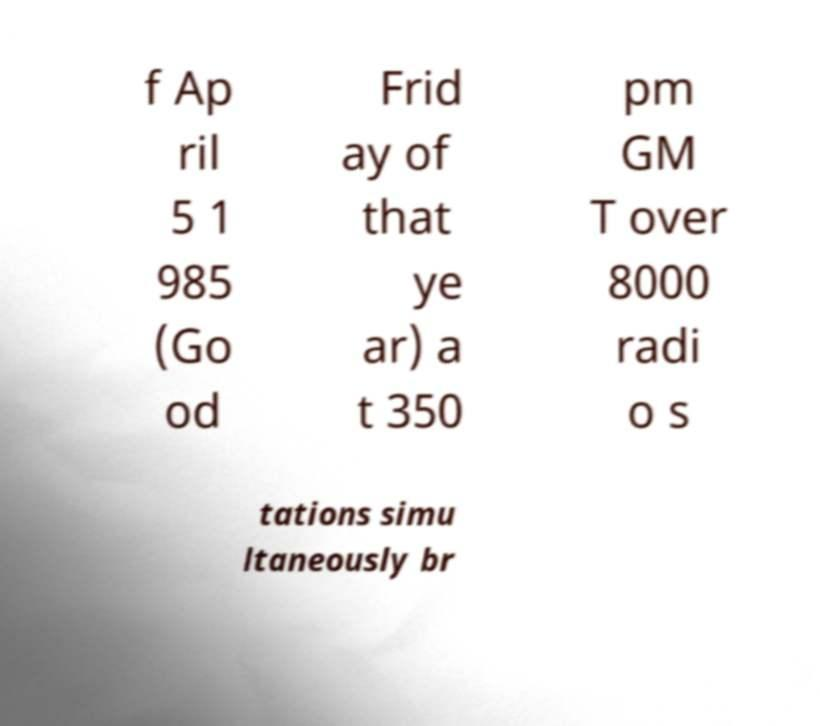Please read and relay the text visible in this image. What does it say? f Ap ril 5 1 985 (Go od Frid ay of that ye ar) a t 350 pm GM T over 8000 radi o s tations simu ltaneously br 